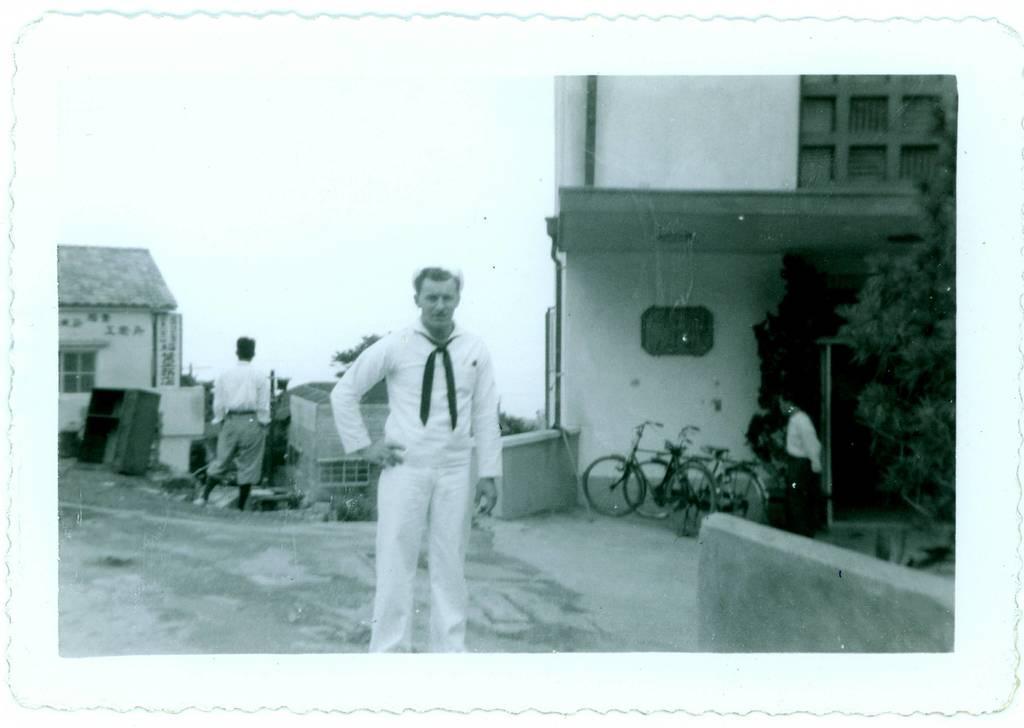How would you summarize this image in a sentence or two? In the picture we can see a black and white picture with a man standing on the path and besides him we can see a house building and some bicycles places near it and on the other side we can also see some other house and a person standing near it. 